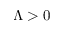Convert formula to latex. <formula><loc_0><loc_0><loc_500><loc_500>\Lambda > 0</formula> 